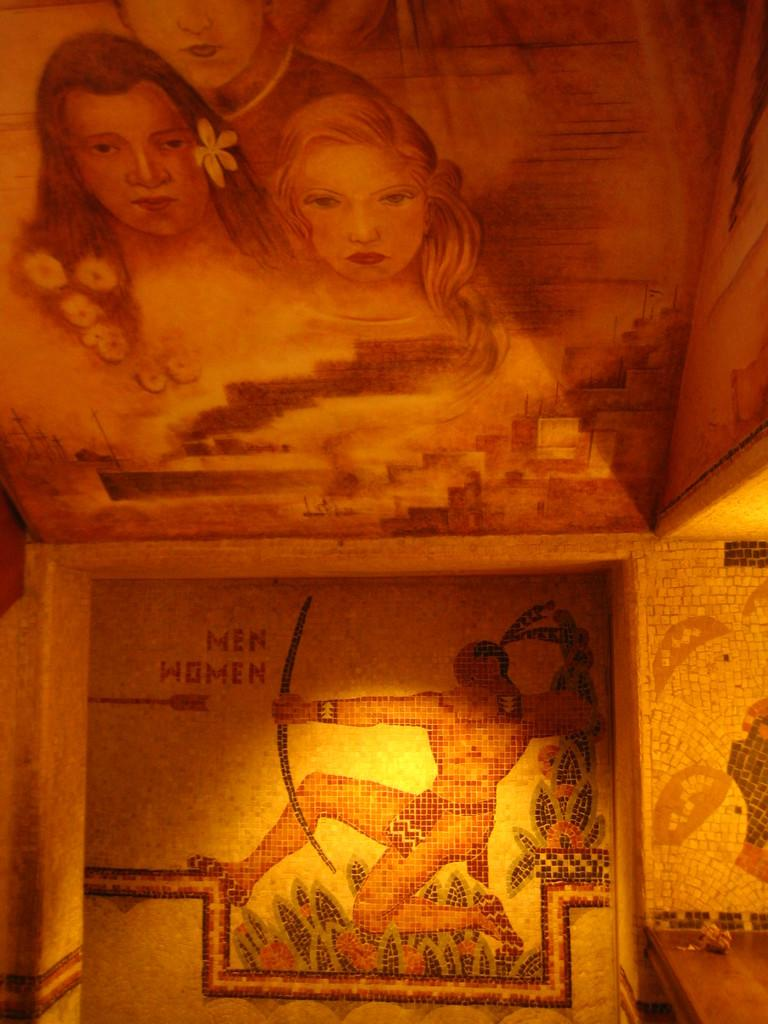What is located on the wooden shelf in the image? There is an object on a wooden shelf in the image. What type of content is present in the image? The image contains art. Can you describe the art in more detail? The art features people and text. Where are the scissors located in the image? There are no scissors present in the image. What role does the slave play in the art? There is no mention of a slave in the image, as the art features people but not in the context of slavery. 